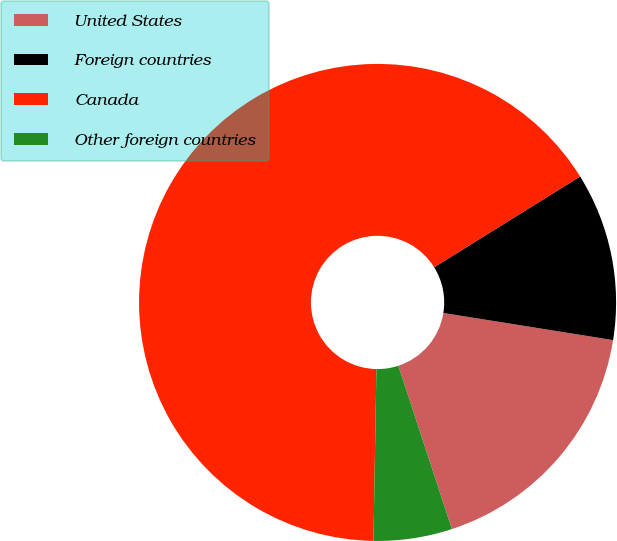<chart> <loc_0><loc_0><loc_500><loc_500><pie_chart><fcel>United States<fcel>Foreign countries<fcel>Canada<fcel>Other foreign countries<nl><fcel>17.43%<fcel>11.38%<fcel>65.87%<fcel>5.32%<nl></chart> 